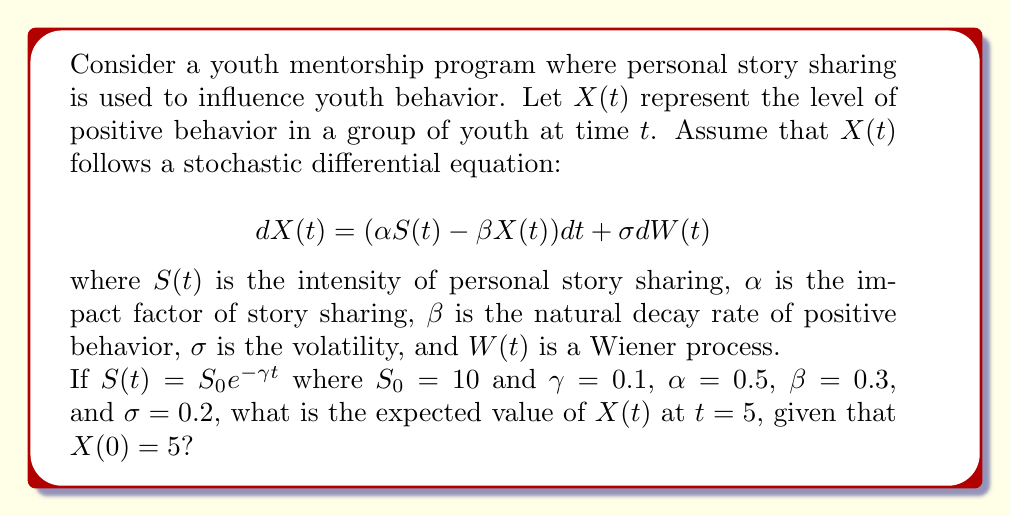Can you solve this math problem? To solve this problem, we need to follow these steps:

1) The general solution for the expected value of $X(t)$ in this type of SDE is:

   $$E[X(t)] = X(0)e^{-\beta t} + \alpha \int_0^t e^{-\beta(t-s)}S(s)ds$$

2) We need to evaluate this integral with $S(t) = S_0e^{-\gamma t}$:

   $$E[X(t)] = X(0)e^{-\beta t} + \alpha S_0 \int_0^t e^{-\beta(t-s)}e^{-\gamma s}ds$$

3) Let's solve the integral:

   $$\int_0^t e^{-\beta(t-s)}e^{-\gamma s}ds = e^{-\beta t}\int_0^t e^{(\beta-\gamma)s}ds$$
   
   $$= e^{-\beta t} \left[\frac{e^{(\beta-\gamma)s}}{\beta-\gamma}\right]_0^t$$
   
   $$= e^{-\beta t} \left[\frac{e^{(\beta-\gamma)t}-1}{\beta-\gamma}\right]$$

4) Substituting this back into our equation:

   $$E[X(t)] = X(0)e^{-\beta t} + \alpha S_0 e^{-\beta t} \left[\frac{e^{(\beta-\gamma)t}-1}{\beta-\gamma}\right]$$

5) Now we can plug in our values:
   $X(0) = 5$, $\alpha = 0.5$, $S_0 = 10$, $\beta = 0.3$, $\gamma = 0.1$, $t = 5$

   $$E[X(5)] = 5e^{-0.3 \cdot 5} + 0.5 \cdot 10 \cdot e^{-0.3 \cdot 5} \left[\frac{e^{(0.3-0.1) \cdot 5}-1}{0.3-0.1}\right]$$

6) Calculating this:

   $$E[X(5)] = 5 \cdot 0.2231 + 5 \cdot 0.2231 \cdot \frac{e^{1}-1}{0.2}$$
   
   $$= 1.1155 + 1.1155 \cdot 8.6936 = 10.8155$$
Answer: $10.8155$ 